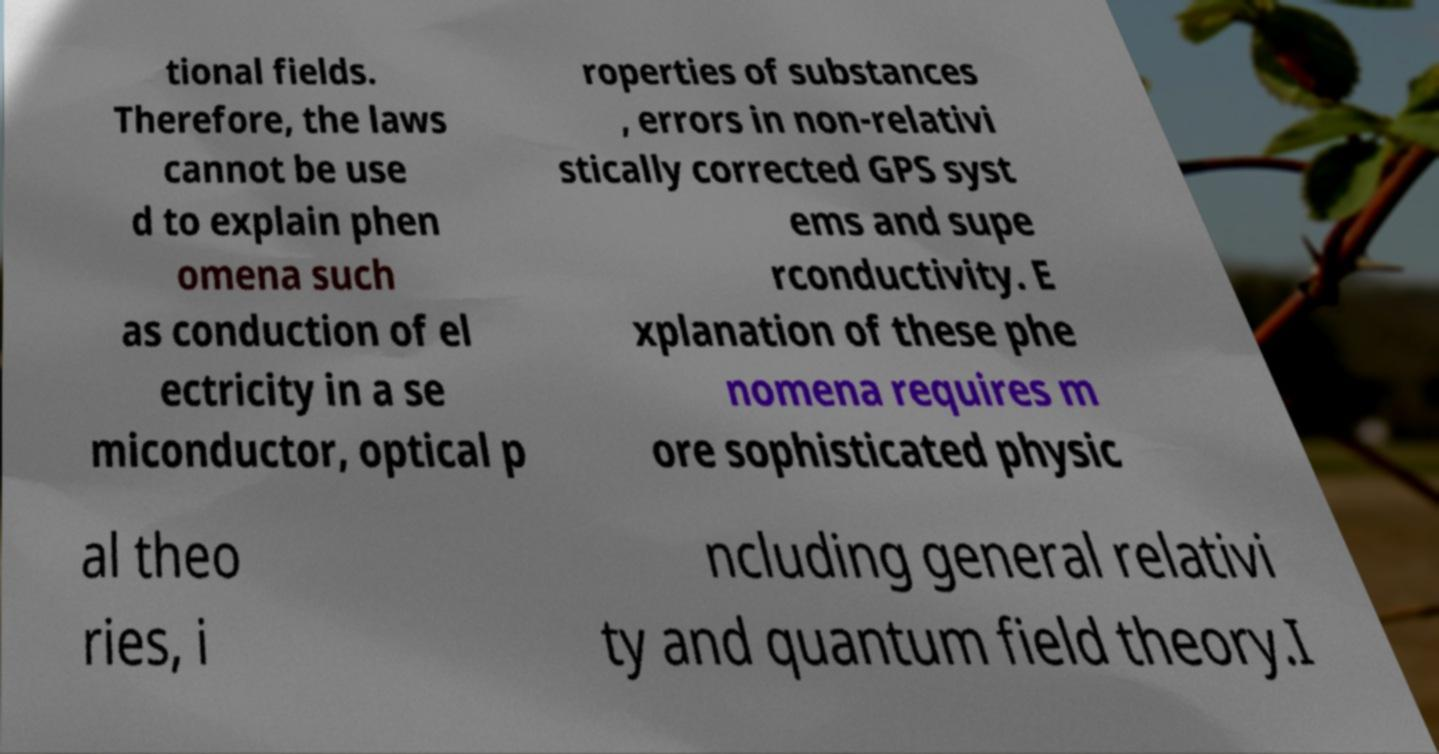Can you accurately transcribe the text from the provided image for me? tional fields. Therefore, the laws cannot be use d to explain phen omena such as conduction of el ectricity in a se miconductor, optical p roperties of substances , errors in non-relativi stically corrected GPS syst ems and supe rconductivity. E xplanation of these phe nomena requires m ore sophisticated physic al theo ries, i ncluding general relativi ty and quantum field theory.I 